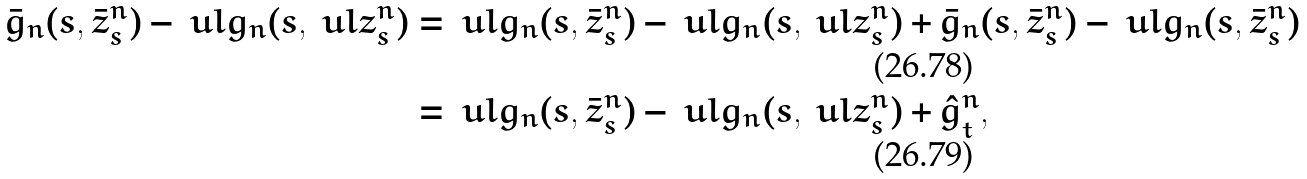Convert formula to latex. <formula><loc_0><loc_0><loc_500><loc_500>\bar { g } _ { n } ( s , \bar { z } _ { s } ^ { n } ) - \ u l { g } _ { n } ( s , \ u l { z } _ { s } ^ { n } ) & = \ u l { g } _ { n } ( s , \bar { z } _ { s } ^ { n } ) - \ u l { g } _ { n } ( s , \ u l { z } _ { s } ^ { n } ) + \bar { g } _ { n } ( s , \bar { z } _ { s } ^ { n } ) - \ u l { g } _ { n } ( s , \bar { z } _ { s } ^ { n } ) \\ & = \ u l { g } _ { n } ( s , \bar { z } _ { s } ^ { n } ) - \ u l { g } _ { n } ( s , \ u l { z } _ { s } ^ { n } ) + \hat { g } _ { t } ^ { n } ,</formula> 